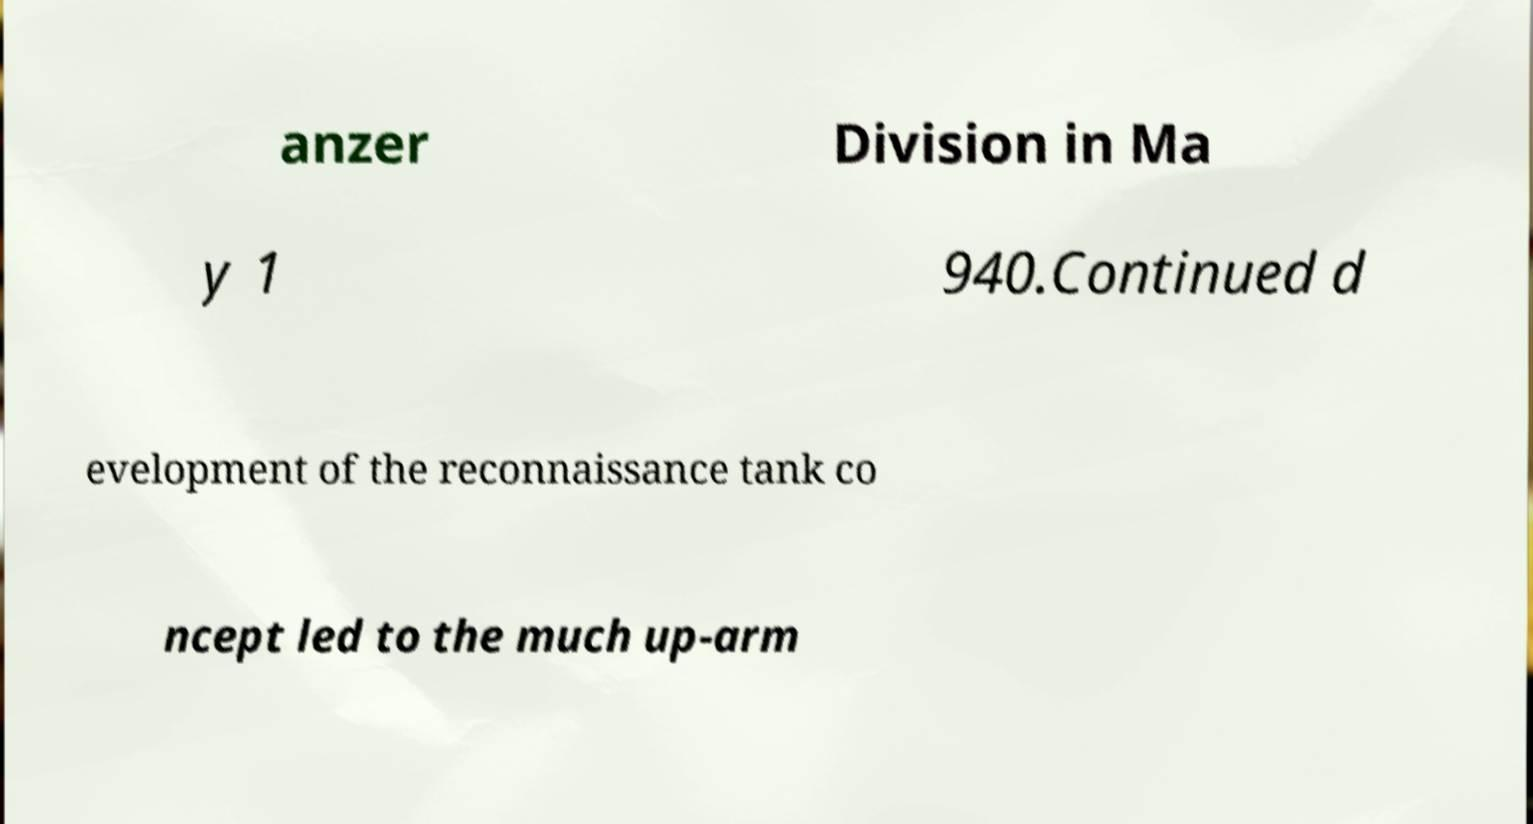Could you extract and type out the text from this image? anzer Division in Ma y 1 940.Continued d evelopment of the reconnaissance tank co ncept led to the much up-arm 